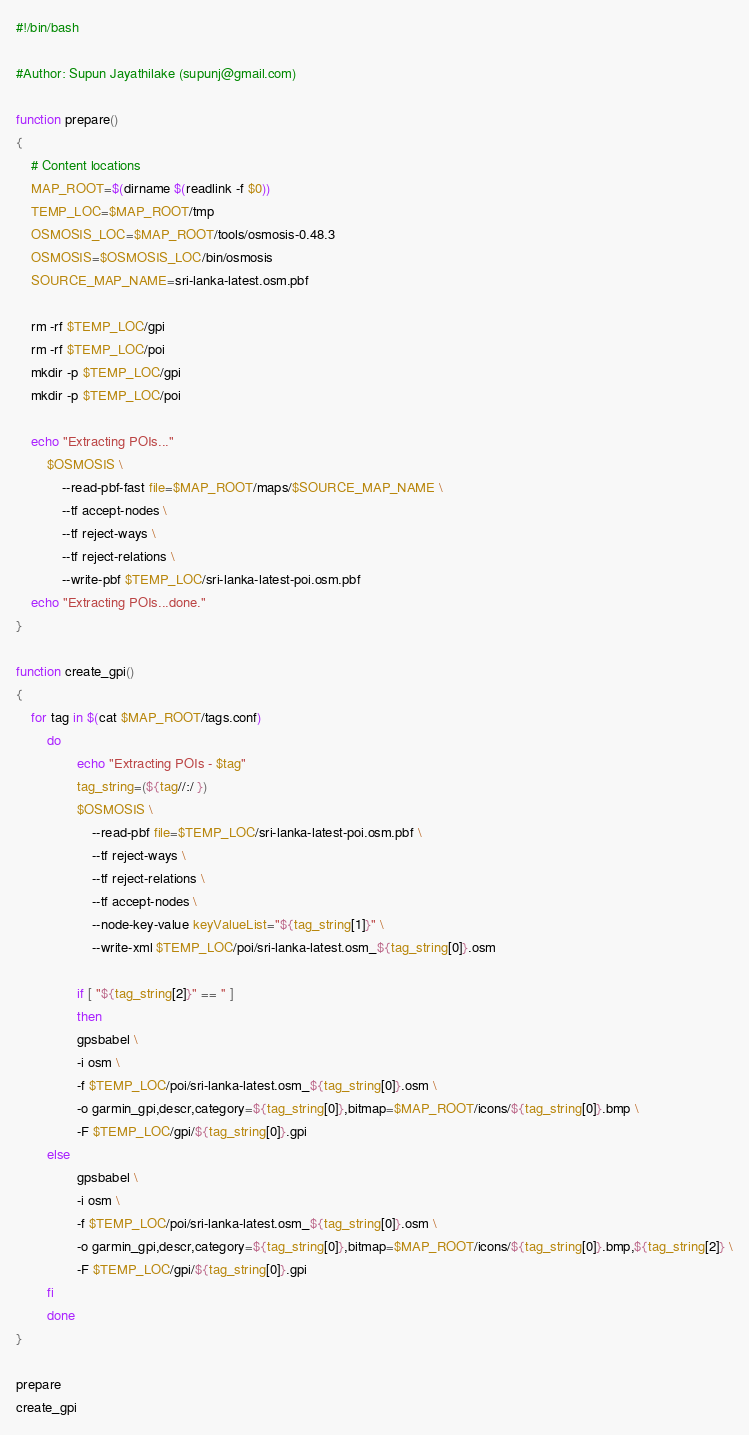Convert code to text. <code><loc_0><loc_0><loc_500><loc_500><_Bash_>#!/bin/bash

#Author: Supun Jayathilake (supunj@gmail.com)

function prepare()
{
	# Content locations
	MAP_ROOT=$(dirname $(readlink -f $0))
	TEMP_LOC=$MAP_ROOT/tmp
	OSMOSIS_LOC=$MAP_ROOT/tools/osmosis-0.48.3
	OSMOSIS=$OSMOSIS_LOC/bin/osmosis	
	SOURCE_MAP_NAME=sri-lanka-latest.osm.pbf
	
	rm -rf $TEMP_LOC/gpi
	rm -rf $TEMP_LOC/poi
  	mkdir -p $TEMP_LOC/gpi
  	mkdir -p $TEMP_LOC/poi
	
	echo "Extracting POIs..."
        $OSMOSIS \
        	--read-pbf-fast file=$MAP_ROOT/maps/$SOURCE_MAP_NAME \
        	--tf accept-nodes \
        	--tf reject-ways \
        	--tf reject-relations \
        	--write-pbf $TEMP_LOC/sri-lanka-latest-poi.osm.pbf
	echo "Extracting POIs...done."
}

function create_gpi()
{	
	for tag in $(cat $MAP_ROOT/tags.conf)
        do
                echo "Extracting POIs - $tag"                
                tag_string=(${tag//:/ })
                $OSMOSIS \
                	--read-pbf file=$TEMP_LOC/sri-lanka-latest-poi.osm.pbf \
                	--tf reject-ways \
                	--tf reject-relations \
                	--tf accept-nodes \
                	--node-key-value keyValueList="${tag_string[1]}" \
                	--write-xml $TEMP_LOC/poi/sri-lanka-latest.osm_${tag_string[0]}.osm
                	
                if [ "${tag_string[2]}" == '' ]
                then
	    		gpsbabel \
				-i osm \
				-f $TEMP_LOC/poi/sri-lanka-latest.osm_${tag_string[0]}.osm \
				-o garmin_gpi,descr,category=${tag_string[0]},bitmap=$MAP_ROOT/icons/${tag_string[0]}.bmp \
				-F $TEMP_LOC/gpi/${tag_string[0]}.gpi
		else
    			gpsbabel \
				-i osm \
				-f $TEMP_LOC/poi/sri-lanka-latest.osm_${tag_string[0]}.osm \
				-o garmin_gpi,descr,category=${tag_string[0]},bitmap=$MAP_ROOT/icons/${tag_string[0]}.bmp,${tag_string[2]} \
				-F $TEMP_LOC/gpi/${tag_string[0]}.gpi
		fi
        done
}

prepare
create_gpi
</code> 